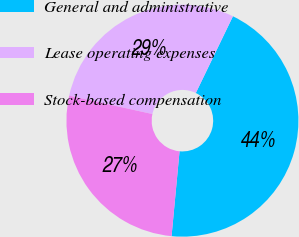Convert chart. <chart><loc_0><loc_0><loc_500><loc_500><pie_chart><fcel>General and administrative<fcel>Lease operating expenses<fcel>Stock-based compensation<nl><fcel>44.32%<fcel>28.71%<fcel>26.97%<nl></chart> 